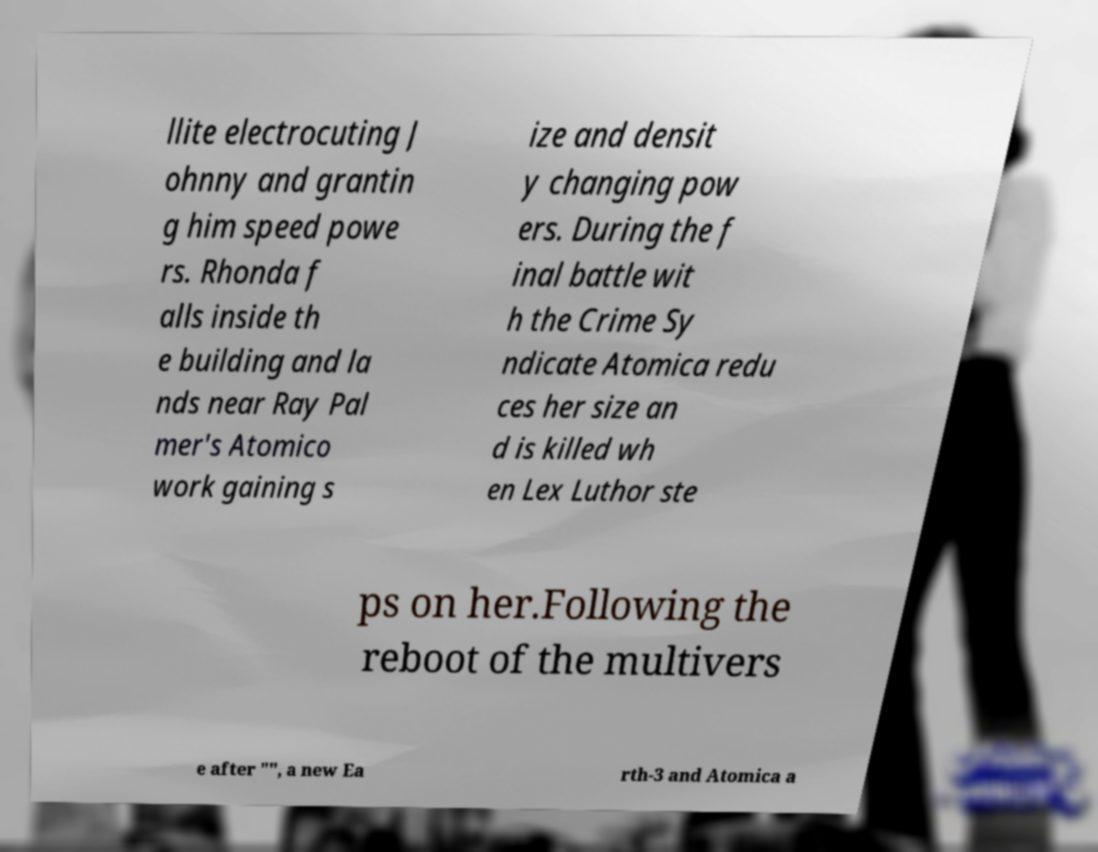For documentation purposes, I need the text within this image transcribed. Could you provide that? llite electrocuting J ohnny and grantin g him speed powe rs. Rhonda f alls inside th e building and la nds near Ray Pal mer's Atomico work gaining s ize and densit y changing pow ers. During the f inal battle wit h the Crime Sy ndicate Atomica redu ces her size an d is killed wh en Lex Luthor ste ps on her.Following the reboot of the multivers e after "", a new Ea rth-3 and Atomica a 